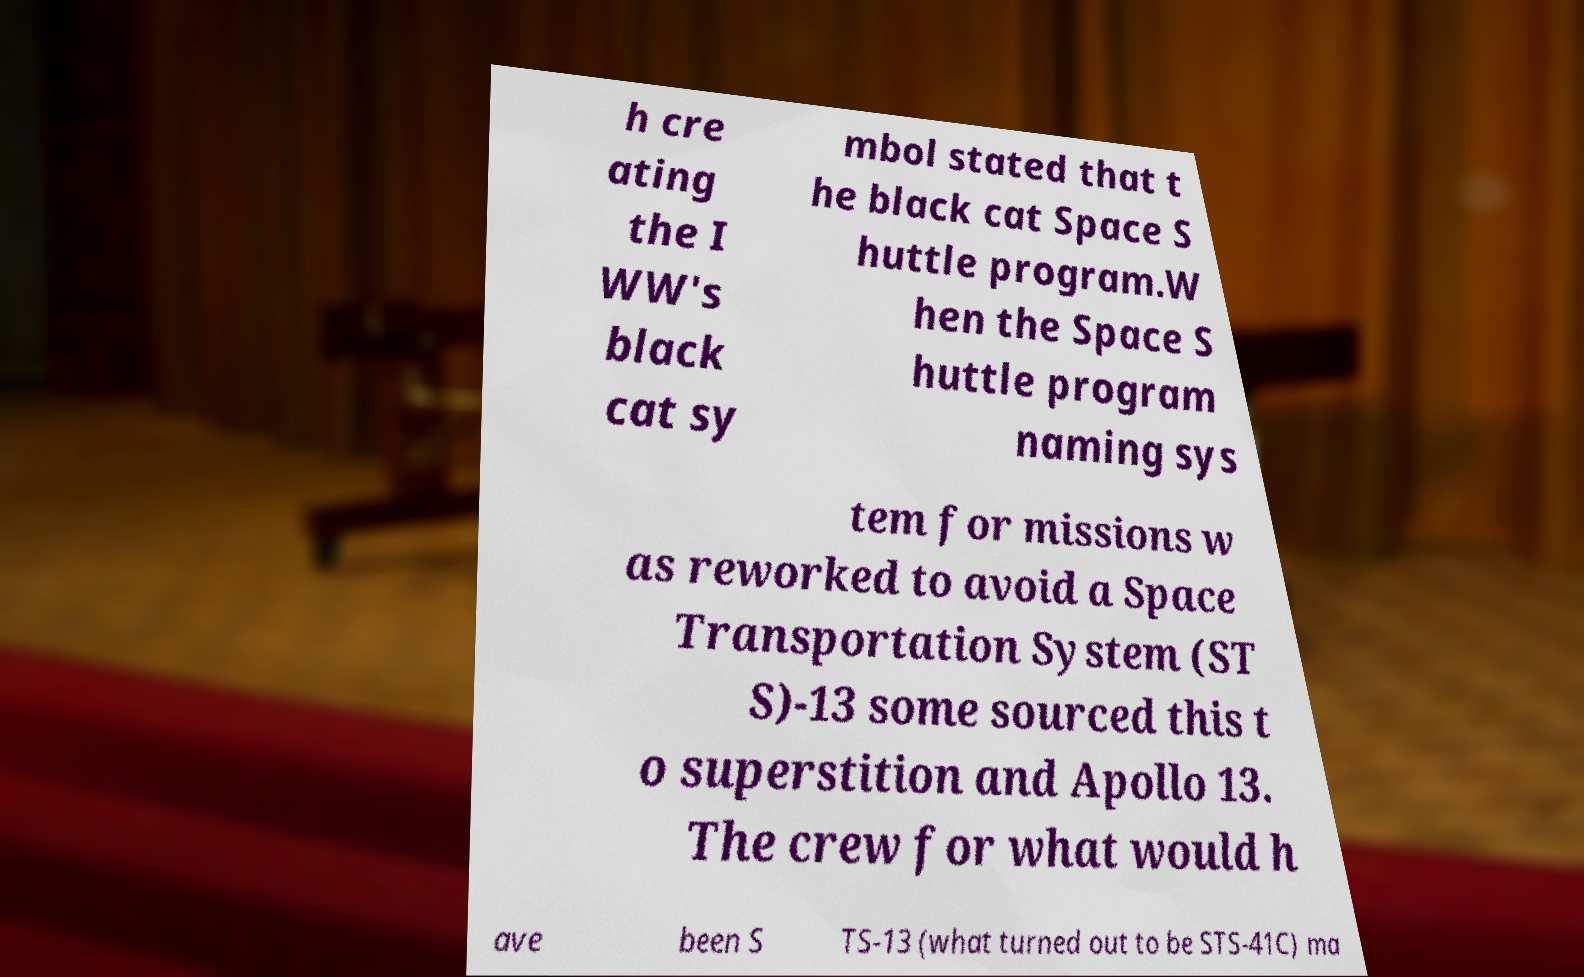What messages or text are displayed in this image? I need them in a readable, typed format. h cre ating the I WW's black cat sy mbol stated that t he black cat Space S huttle program.W hen the Space S huttle program naming sys tem for missions w as reworked to avoid a Space Transportation System (ST S)-13 some sourced this t o superstition and Apollo 13. The crew for what would h ave been S TS-13 (what turned out to be STS-41C) ma 